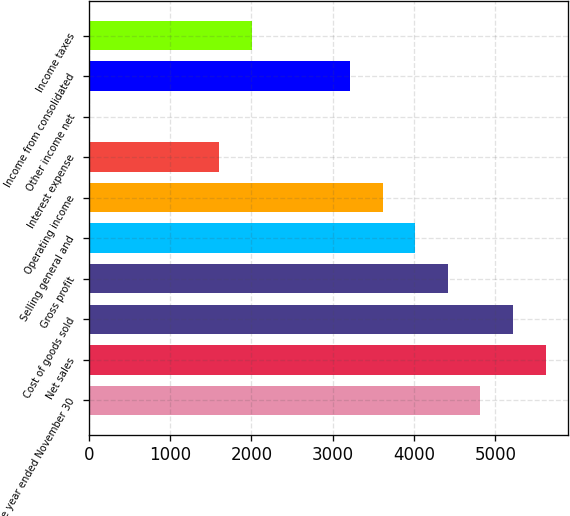Convert chart. <chart><loc_0><loc_0><loc_500><loc_500><bar_chart><fcel>for the year ended November 30<fcel>Net sales<fcel>Cost of goods sold<fcel>Gross profit<fcel>Selling general and<fcel>Operating income<fcel>Interest expense<fcel>Other income net<fcel>Income from consolidated<fcel>Income taxes<nl><fcel>4816.56<fcel>5618.92<fcel>5217.74<fcel>4415.38<fcel>4014.2<fcel>3613.02<fcel>1607.12<fcel>2.4<fcel>3211.84<fcel>2008.3<nl></chart> 